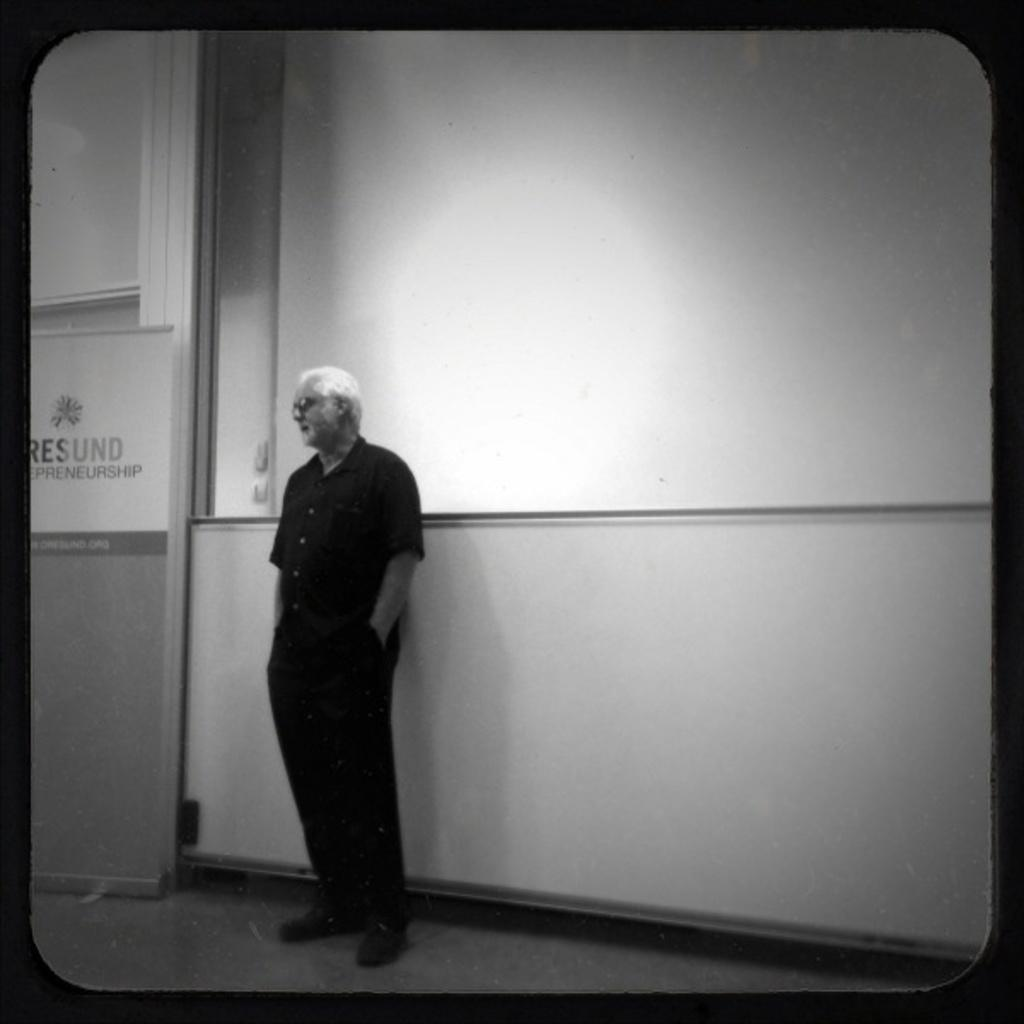What is the main subject of the image? There is a person standing in the image. What object can be seen in the image besides the person? There is a board in the image. What type of wall is present in the image? There is a glass wall in the image. What color scheme is used in the image? The image is in black and white. How many cards does the person have in their hand in the image? There are no cards visible in the image; it only features a person, a board, and a glass wall. 